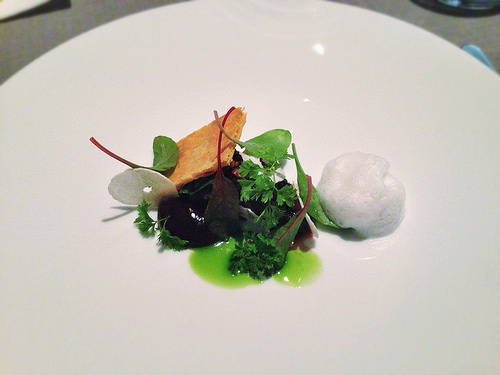<image>
Is there a plate behind the food? No. The plate is not behind the food. From this viewpoint, the plate appears to be positioned elsewhere in the scene. 